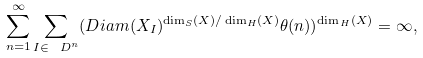<formula> <loc_0><loc_0><loc_500><loc_500>\sum _ { n = 1 } ^ { \infty } \sum _ { I \in \ D ^ { n } } ( D i a m ( X _ { I } ) ^ { \dim _ { S } ( X ) / \dim _ { H } ( X ) } \theta ( n ) ) ^ { \dim _ { H } ( X ) } = \infty ,</formula> 